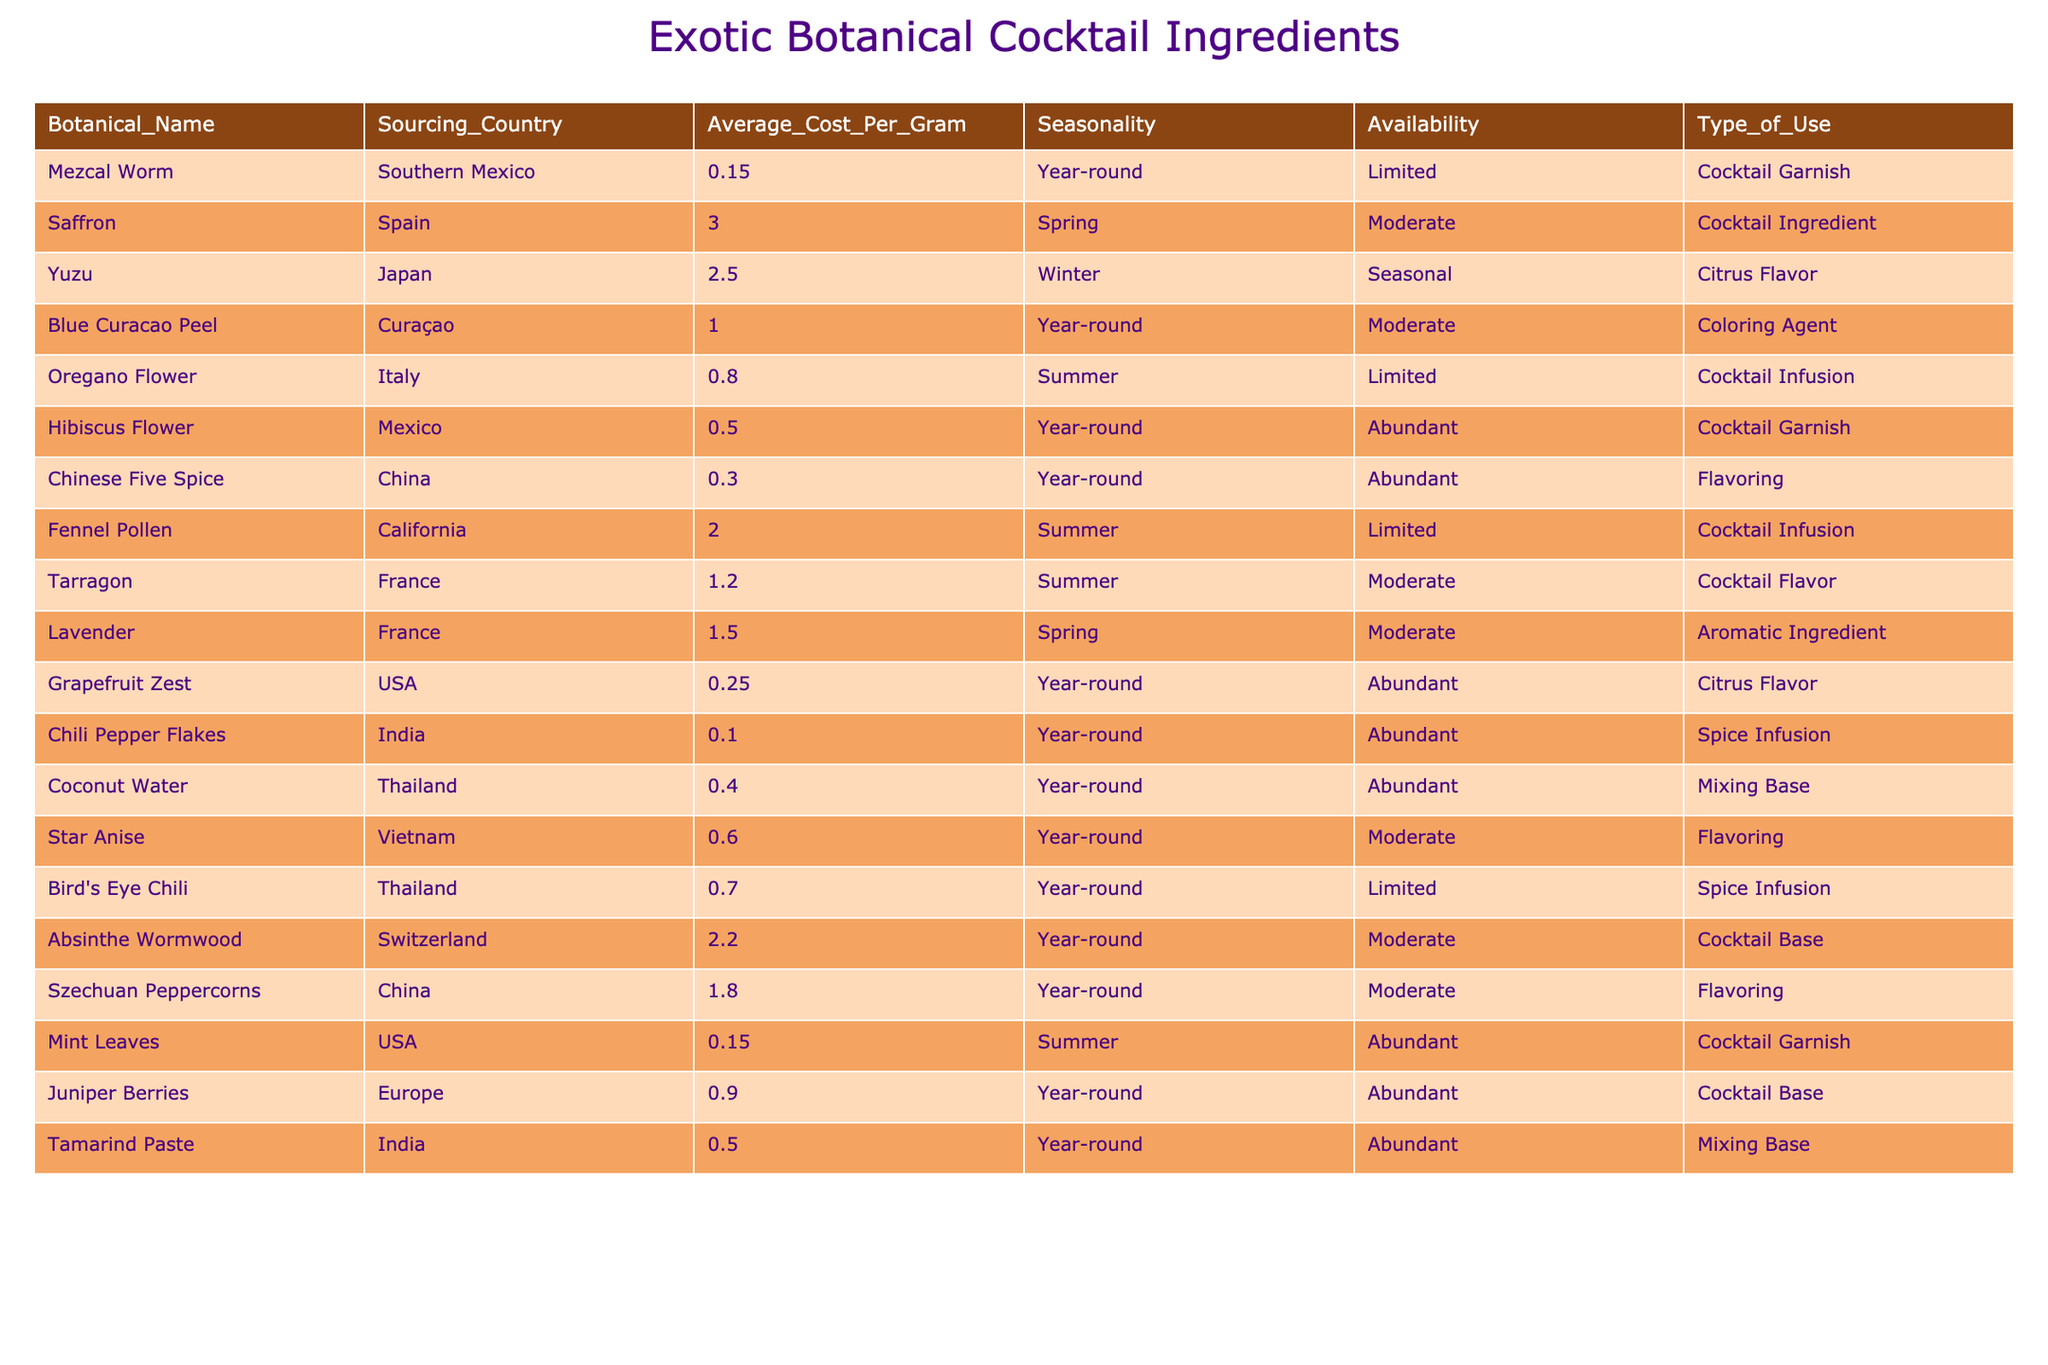What is the most expensive botanical ingredient in the table? By examining the "Average_Cost_Per_Gram" column, the highest value found is for Saffron at 3.00 per gram, which is greater than all other listed prices.
Answer: Saffron How many ingredients are sourced from Year-round availability? A count of the "Availability" column shows there are 12 ingredients marked as Year-round, indicating they can be sourced throughout the entire year.
Answer: 12 Which botanical has the lowest sourcing cost, and what is that cost? Looking up the "Average_Cost_Per_Gram" column, the botanical with the lowest cost is Chili Pepper Flakes at 0.10 per gram, making it the cheapest option available.
Answer: 0.10 Is there any botanical that has Limited availability and is used as a Cocktail Garnish? By checking the "Availability" and "Type_of_Use" columns, only the Mezcal Worm has Limited availability and is used as a Cocktail Garnish, confirming the statement is true.
Answer: Yes What is the average cost per gram of botanicals sourced from India? The botanicals sourced from India are Chili Pepper Flakes at 0.10 and Tamarind Paste at 0.50. The average is calculated as (0.10 + 0.50) / 2 = 0.30.
Answer: 0.30 Which ingredient has the highest cost in the Spring season? Observing the "Seasonality" and "Average_Cost_Per_Gram" columns, Saffron at 3.00 is the only botanical listed in Spring, receiving the highest cost for that season.
Answer: Saffron Are there any botanicals from France that have Moderate availability? The data shows that both Tarragon and Lavender are sourced from France and categorized as Moderate availability, confirming there are such botanicals.
Answer: Yes How much more expensive is Yuzu compared to Grapefruit Zest? The average cost of Yuzu is 2.50 and Grapefruit Zest is 0.25; the difference is 2.50 - 0.25 = 2.25, indicating Yuzu is significantly more expensive.
Answer: 2.25 What type of use does the Absinthe Wormwood have, and what is its average cost? The Absinthe Wormwood is used as a Cocktail Base and costs 2.20 per gram, both details are drawn from the respective columns of the table.
Answer: Cocktail Base, 2.20 Which botanical has abundant availability and costs less than 1.00 per gram? Reviewing the "Availability" and "Average_Cost_Per_Gram" columns, the Hibiscus Flower at 0.50 counts as it is classified as both abundant and under 1.00.
Answer: Hibiscus Flower How does the average cost of botanicals from Mexico compare to the overall average cost of all botanicals listed? The average cost of the botanicals from Mexico (Mezcal Worm at 0.15 and Hibiscus Flower at 0.50) is (0.15 + 0.50) / 2 = 0.325. The overall average overall is calculated from all values, which would be higher at approximately 0.85, thus showing that Mexican botanicals are more affordable.
Answer: Lower than overall average 